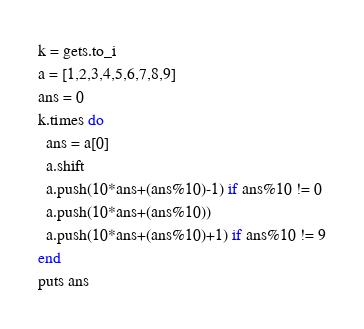<code> <loc_0><loc_0><loc_500><loc_500><_Ruby_>k = gets.to_i
a = [1,2,3,4,5,6,7,8,9]
ans = 0
k.times do
  ans = a[0]
  a.shift
  a.push(10*ans+(ans%10)-1) if ans%10 != 0
  a.push(10*ans+(ans%10))
  a.push(10*ans+(ans%10)+1) if ans%10 != 9
end
puts ans</code> 